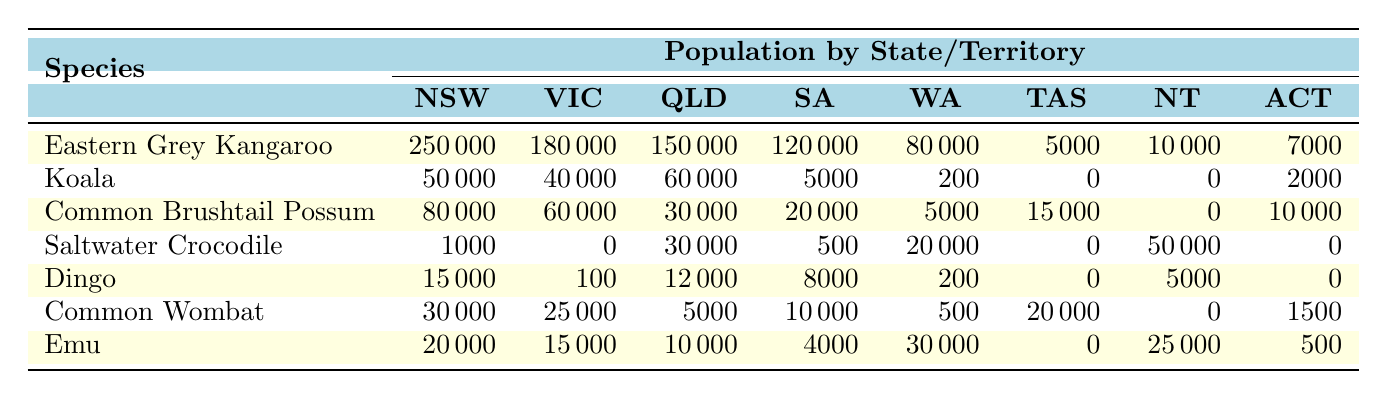What is the population of the Eastern Grey Kangaroo in New South Wales? The table shows the population of the Eastern Grey Kangaroo in New South Wales as 250,000.
Answer: 250000 Which species has the highest population in Victoria? The table lists the Eastern Grey Kangaroo with a population of 180,000 in Victoria, which is higher than any other species in that state.
Answer: Eastern Grey Kangaroo How many more Eastern Grey Kangaroos are there in New South Wales compared to Queensland? The population in New South Wales is 250,000 and in Queensland it is 150,000. The difference is 250,000 - 150,000 = 100,000.
Answer: 100000 What is the total population of Common Brushtail Possums across all states? The populations listed are: 80,000 (NSW) + 60,000 (VIC) + 30,000 (QLD) + 20,000 (SA) + 5,000 (WA) + 15,000 (TAS) + 0 (NT) + 10,000 (ACT) = 220,000 total.
Answer: 220000 Is there a population of Koalas in Tasmania? The table indicates that the population of Koalas in Tasmania is 0.
Answer: No What is the average population of Emus across all states? The populations for Emus are: 20,000 (NSW), 15,000 (VIC), 10,000 (QLD), 4,000 (SA), 30,000 (WA), 0 (TAS), 25,000 (NT), and 500 (ACT). Their sum is 20,000 + 15,000 + 10,000 + 4,000 + 30,000 + 0 + 25,000 + 500 = 104,500, and then divided by the number of states, which is 8: 104,500 / 8 = 13,062.5.
Answer: 13062.5 Which species has the lowest observed population in Queensland? Looking at the table, the Dingo has a population of 12,000 while Saltwater Crocodile has 30,000, so it has a higher population than Dingo. The species with the lowest in Queensland is the Common Wombat with just 5,000.
Answer: Common Wombat Are there any species that have a population of zero in South Australia? By inspecting the table, the Koala and the Saltwater Crocodile both show populations of zero in South Australia.
Answer: Yes What is the total population of Saltwater Crocodiles in Australia? The populations listed are: 1,000 (NSW) + 0 (VIC) + 30,000 (QLD) + 500 (SA) + 20,000 (WA) + 0 (TAS) + 50,000 (NT) + 0 (ACT). The total is 1,000 + 0 + 30,000 + 500 + 20,000 + 0 + 50,000 + 0 = 101,500.
Answer: 101500 What is the highest population among all species in the Northern Territory? In the Northern Territory, the Saltwater Crocodile has a population of 50,000, which is more than any other species based on the table data.
Answer: Saltwater Crocodile 